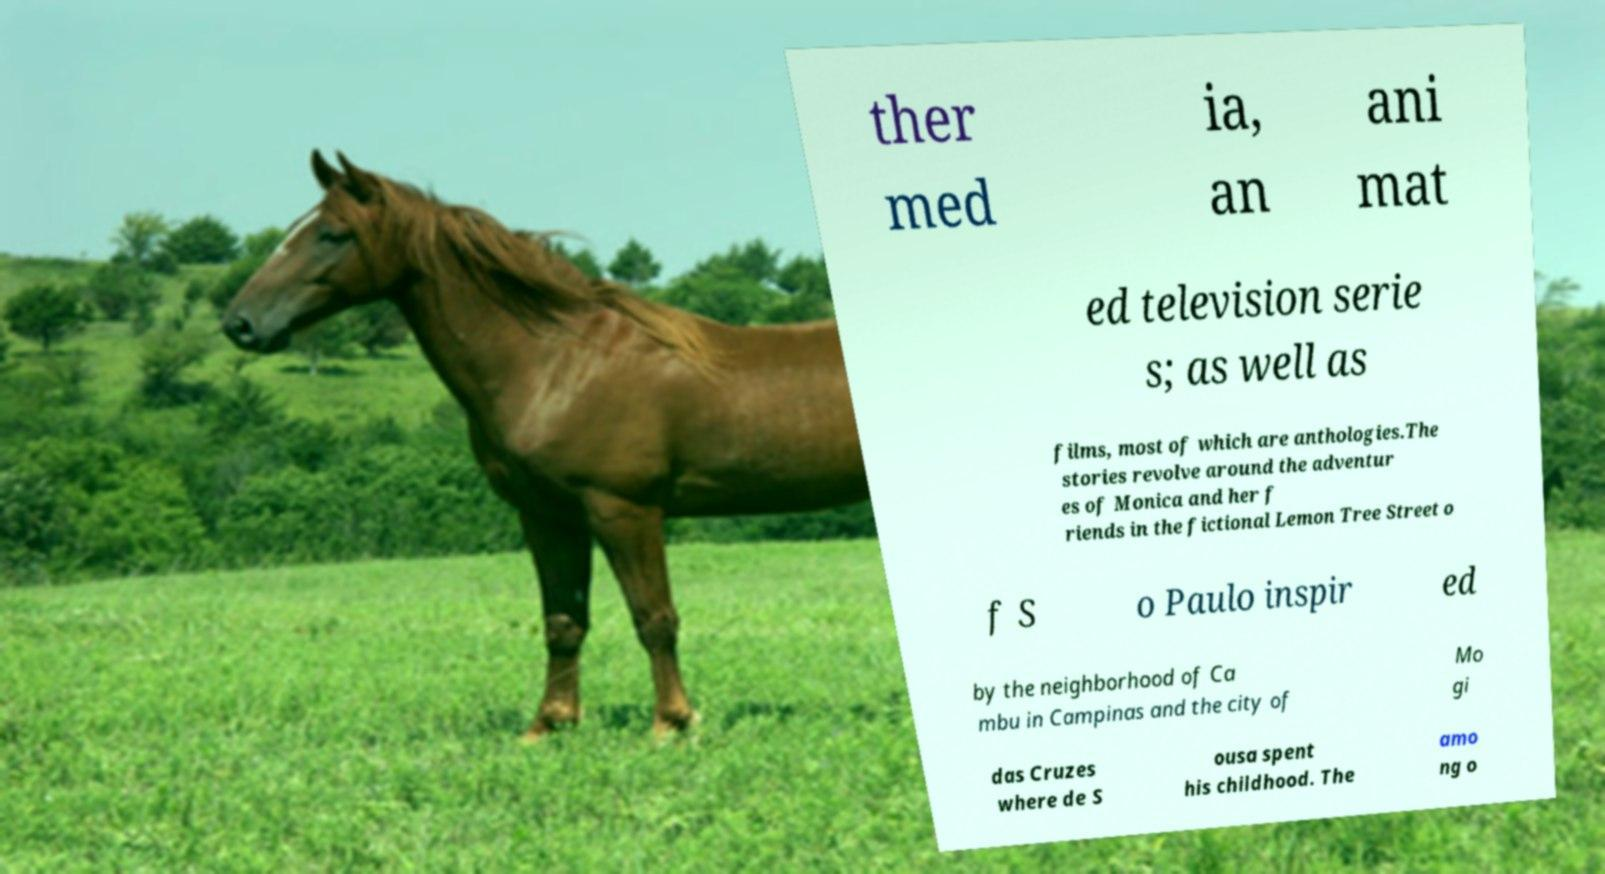Could you assist in decoding the text presented in this image and type it out clearly? ther med ia, an ani mat ed television serie s; as well as films, most of which are anthologies.The stories revolve around the adventur es of Monica and her f riends in the fictional Lemon Tree Street o f S o Paulo inspir ed by the neighborhood of Ca mbu in Campinas and the city of Mo gi das Cruzes where de S ousa spent his childhood. The amo ng o 